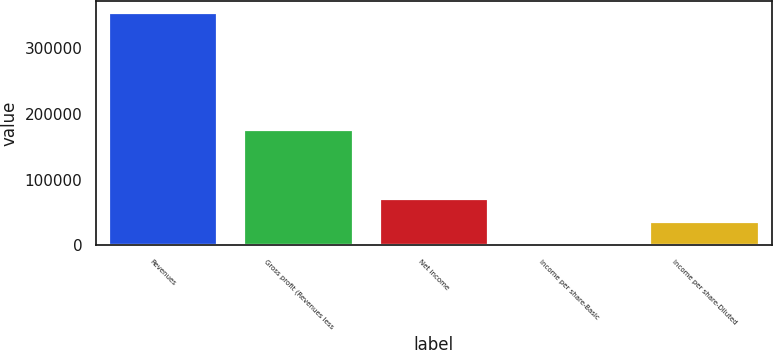Convert chart. <chart><loc_0><loc_0><loc_500><loc_500><bar_chart><fcel>Revenues<fcel>Gross profit (Revenues less<fcel>Net income<fcel>Income per share-Basic<fcel>Income per share-Diluted<nl><fcel>352736<fcel>174934<fcel>70547.3<fcel>0.15<fcel>35273.7<nl></chart> 